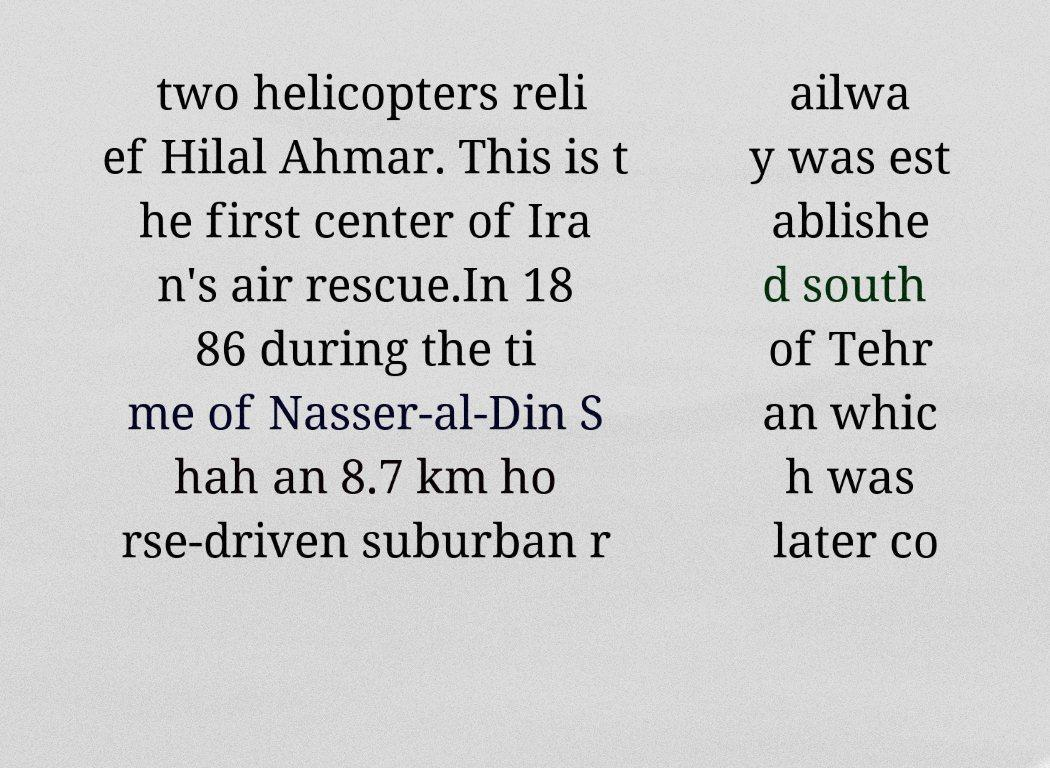I need the written content from this picture converted into text. Can you do that? two helicopters reli ef Hilal Ahmar. This is t he first center of Ira n's air rescue.In 18 86 during the ti me of Nasser-al-Din S hah an 8.7 km ho rse-driven suburban r ailwa y was est ablishe d south of Tehr an whic h was later co 